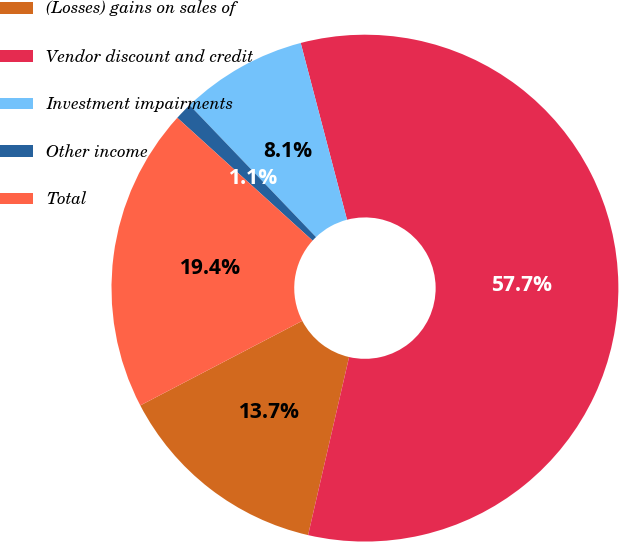Convert chart to OTSL. <chart><loc_0><loc_0><loc_500><loc_500><pie_chart><fcel>(Losses) gains on sales of<fcel>Vendor discount and credit<fcel>Investment impairments<fcel>Other income<fcel>Total<nl><fcel>13.74%<fcel>57.68%<fcel>8.08%<fcel>1.11%<fcel>19.39%<nl></chart> 